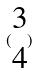<formula> <loc_0><loc_0><loc_500><loc_500>( \begin{matrix} 3 \\ 4 \end{matrix} )</formula> 